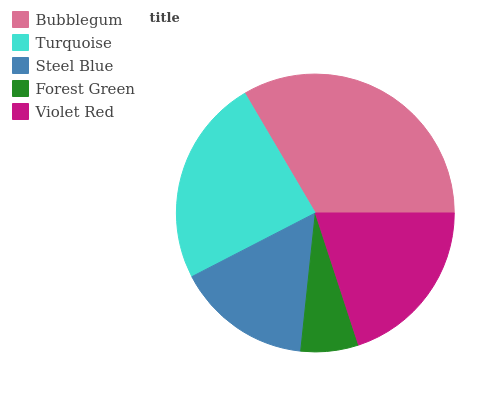Is Forest Green the minimum?
Answer yes or no. Yes. Is Bubblegum the maximum?
Answer yes or no. Yes. Is Turquoise the minimum?
Answer yes or no. No. Is Turquoise the maximum?
Answer yes or no. No. Is Bubblegum greater than Turquoise?
Answer yes or no. Yes. Is Turquoise less than Bubblegum?
Answer yes or no. Yes. Is Turquoise greater than Bubblegum?
Answer yes or no. No. Is Bubblegum less than Turquoise?
Answer yes or no. No. Is Violet Red the high median?
Answer yes or no. Yes. Is Violet Red the low median?
Answer yes or no. Yes. Is Bubblegum the high median?
Answer yes or no. No. Is Turquoise the low median?
Answer yes or no. No. 